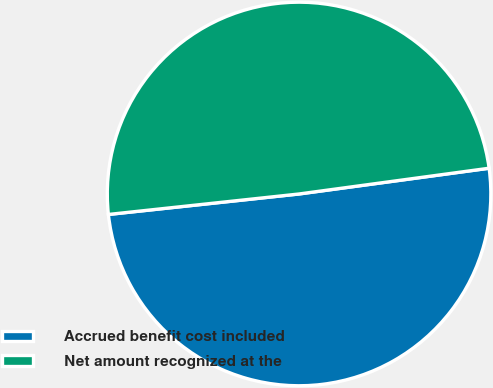<chart> <loc_0><loc_0><loc_500><loc_500><pie_chart><fcel>Accrued benefit cost included<fcel>Net amount recognized at the<nl><fcel>50.44%<fcel>49.56%<nl></chart> 